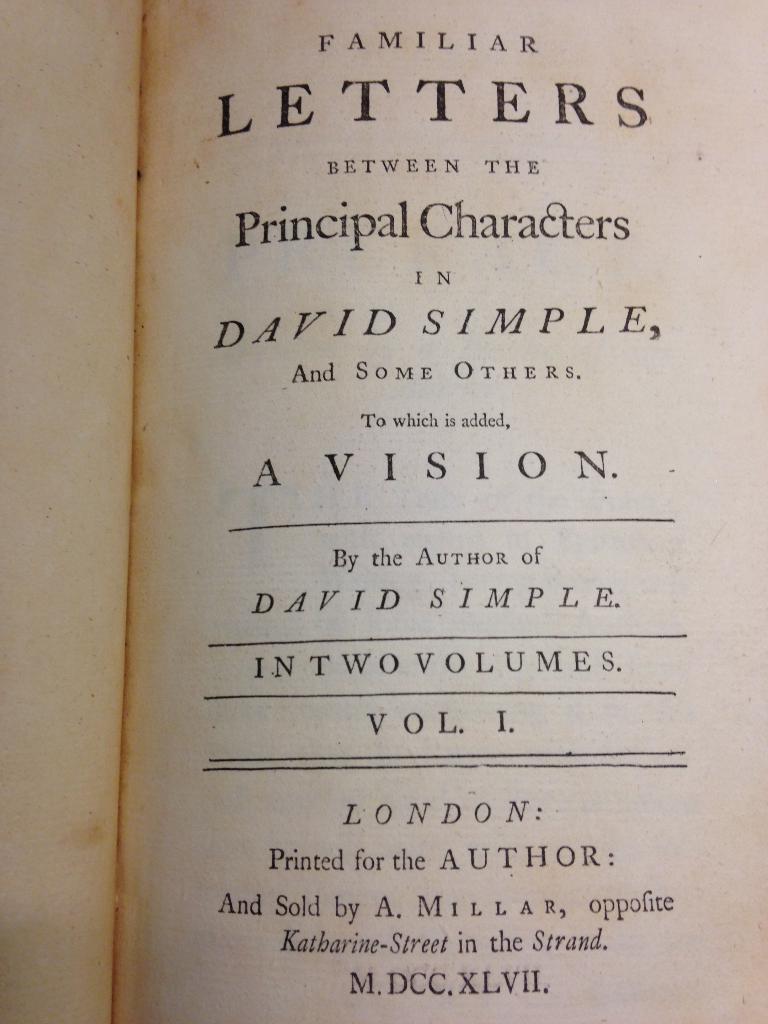What volume is this?
Offer a very short reply. 1. 